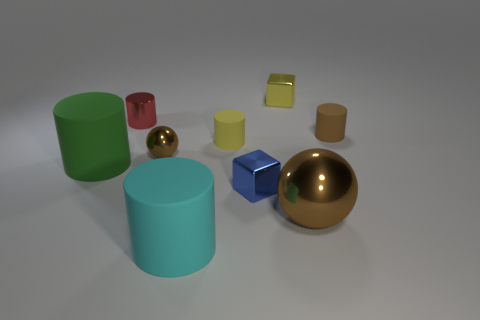Subtract all large cyan cylinders. How many cylinders are left? 4 Add 1 large red balls. How many objects exist? 10 Subtract all red cylinders. How many cylinders are left? 4 Subtract 1 cylinders. How many cylinders are left? 4 Subtract all blocks. How many objects are left? 7 Subtract all green cylinders. Subtract all blue cubes. How many cylinders are left? 4 Subtract all green rubber things. Subtract all tiny shiny cubes. How many objects are left? 6 Add 3 big green objects. How many big green objects are left? 4 Add 3 large blue balls. How many large blue balls exist? 3 Subtract 1 blue cubes. How many objects are left? 8 